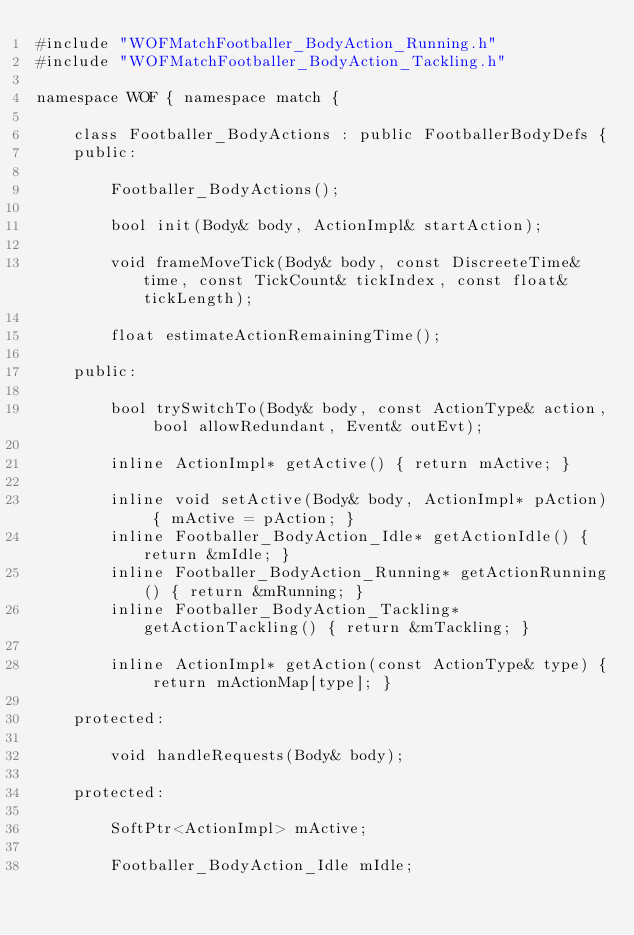Convert code to text. <code><loc_0><loc_0><loc_500><loc_500><_C_>#include "WOFMatchFootballer_BodyAction_Running.h"
#include "WOFMatchFootballer_BodyAction_Tackling.h"

namespace WOF { namespace match {

	class Footballer_BodyActions : public FootballerBodyDefs {
	public:
	
		Footballer_BodyActions();

		bool init(Body& body, ActionImpl& startAction);

		void frameMoveTick(Body& body, const DiscreeteTime& time, const TickCount& tickIndex, const float& tickLength);
			
		float estimateActionRemainingTime();

	public:

		bool trySwitchTo(Body& body, const ActionType& action, bool allowRedundant, Event& outEvt);

		inline ActionImpl* getActive() { return mActive; }

		inline void setActive(Body& body, ActionImpl* pAction) { mActive = pAction; }
		inline Footballer_BodyAction_Idle* getActionIdle() { return &mIdle; }
		inline Footballer_BodyAction_Running* getActionRunning() { return &mRunning; }
		inline Footballer_BodyAction_Tackling* getActionTackling() { return &mTackling; }

		inline ActionImpl* getAction(const ActionType& type) { return mActionMap[type]; }
			
	protected:

		void handleRequests(Body& body);

	protected:

		SoftPtr<ActionImpl> mActive;

		Footballer_BodyAction_Idle mIdle;</code> 